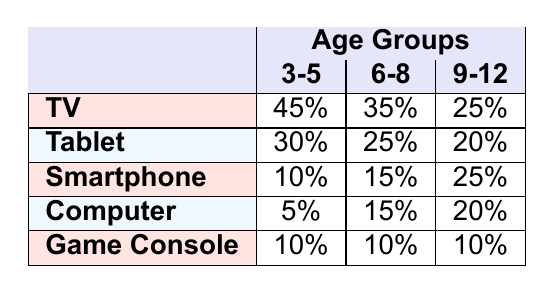What percentage of screen time do 3-5 year-olds spend on a TV? Referring to the table, the percentage of screen time for 3-5 year-olds using a TV is listed directly. It shows 45%.
Answer: 45% What device do 6-8 year-olds spend the least percentage of their screen time on? Looking at the table, for the age group 6-8, the device with the lowest percentage is the Game Console, which is 10%.
Answer: Game Console What is the total percentage of screen time spent on Tablets by children aged 3-12? To find the total, we sum the percentages for Tablets in each age group: 30% (3-5) + 25% (6-8) + 20% (9-12) = 75%.
Answer: 75% How does screen time for Smartphones compare between 6-8 year-olds and 9-12 year-olds? The screen time for 6-8 year-olds is 15%, while for 9-12 year-olds, it is 25%. Therefore, the 9-12 age group spends 10% more time on Smartphones.
Answer: 10% more What is the average percentage of screen time for all devices among children aged 3-5? To calculate the average, we will sum all the percentages for age group 3-5: 45% (TV) + 30% (Tablet) + 10% (Smartphone) + 5% (Computer) + 10% (Game Console) = 100%. Dividing by 5 devices gives us an average of 20%.
Answer: 20% Is it true that children aged 9-12 spend more time on Tablets than on Game Consoles? From the table, children aged 9-12 spend 20% of their screen time on Tablets and 10% on Game Consoles. Hence, the statement is true.
Answer: Yes What device has the highest percentage of screen time for children aged 3-5? Referring to the table, the device with the highest screen time percentage for 3-5 year-olds is TV, with 45%.
Answer: TV Which age group spends the same percentage of screen time on Game Consoles? Examining the table, we see that all age groups (3-5, 6-8, and 9-12) spend 10% of their screen time on Game Consoles, making it uniform across the board.
Answer: All age groups What is the difference in screen time percentage on Computers between ages 6-8 and 9-12? For 6-8 year-olds, the percentage is 15%, and for 9-12 year-olds, it's 20%. The difference is calculated as 20% - 15% = 5%.
Answer: 5% Which device's usage percentage decreases the most as the age increases from 3-5 to 9-12? Analyzing the table, the TV's usage decreases from 45% (3-5) to 25% (9-12), a difference of 20%. This is the largest decrease compared to other devices.
Answer: TV 